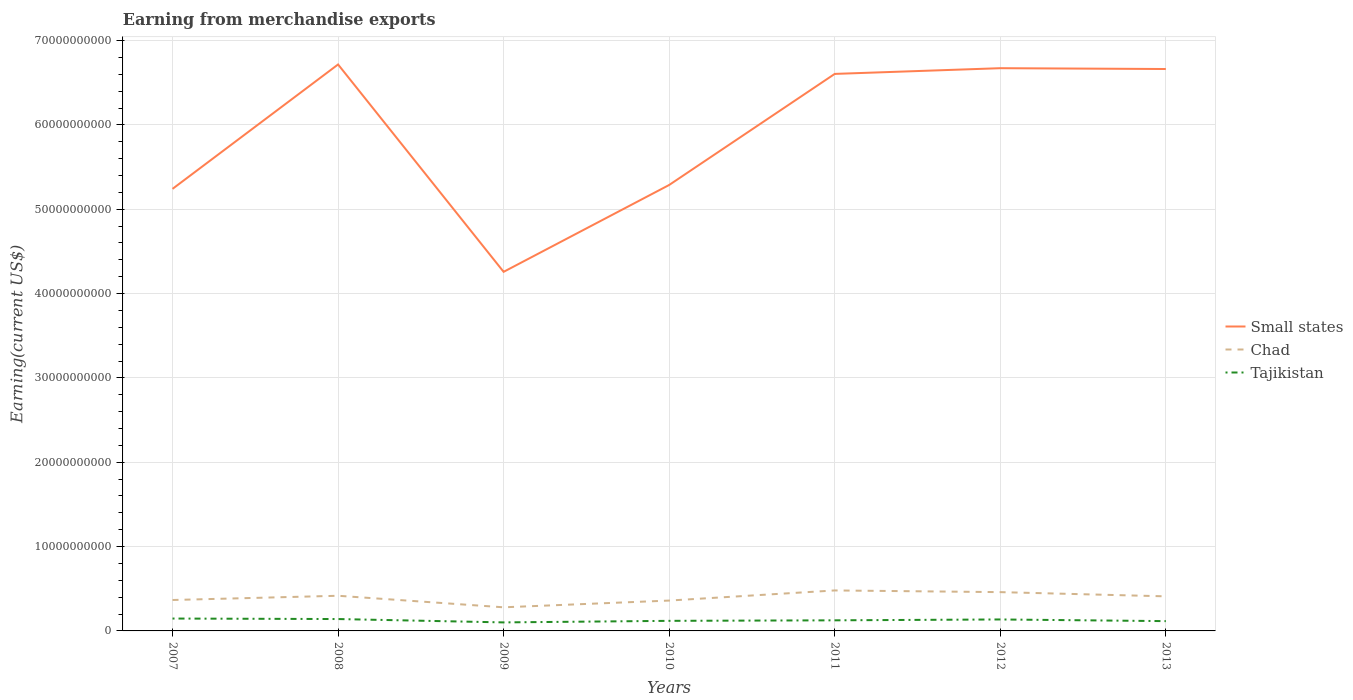Does the line corresponding to Tajikistan intersect with the line corresponding to Chad?
Provide a succinct answer. No. Is the number of lines equal to the number of legend labels?
Your answer should be very brief. Yes. Across all years, what is the maximum amount earned from merchandise exports in Tajikistan?
Give a very brief answer. 1.01e+09. What is the total amount earned from merchandise exports in Chad in the graph?
Your response must be concise. -6.31e+08. How many lines are there?
Give a very brief answer. 3. How many years are there in the graph?
Provide a succinct answer. 7. Does the graph contain any zero values?
Keep it short and to the point. No. Where does the legend appear in the graph?
Make the answer very short. Center right. What is the title of the graph?
Provide a short and direct response. Earning from merchandise exports. What is the label or title of the X-axis?
Provide a succinct answer. Years. What is the label or title of the Y-axis?
Provide a short and direct response. Earning(current US$). What is the Earning(current US$) of Small states in 2007?
Your answer should be compact. 5.24e+1. What is the Earning(current US$) in Chad in 2007?
Your answer should be very brief. 3.67e+09. What is the Earning(current US$) in Tajikistan in 2007?
Provide a short and direct response. 1.47e+09. What is the Earning(current US$) in Small states in 2008?
Your answer should be very brief. 6.72e+1. What is the Earning(current US$) in Chad in 2008?
Provide a succinct answer. 4.17e+09. What is the Earning(current US$) of Tajikistan in 2008?
Provide a succinct answer. 1.41e+09. What is the Earning(current US$) in Small states in 2009?
Provide a succinct answer. 4.26e+1. What is the Earning(current US$) of Chad in 2009?
Offer a terse response. 2.80e+09. What is the Earning(current US$) of Tajikistan in 2009?
Provide a succinct answer. 1.01e+09. What is the Earning(current US$) of Small states in 2010?
Ensure brevity in your answer.  5.29e+1. What is the Earning(current US$) of Chad in 2010?
Your answer should be very brief. 3.60e+09. What is the Earning(current US$) in Tajikistan in 2010?
Your response must be concise. 1.20e+09. What is the Earning(current US$) of Small states in 2011?
Your answer should be very brief. 6.60e+1. What is the Earning(current US$) of Chad in 2011?
Ensure brevity in your answer.  4.80e+09. What is the Earning(current US$) in Tajikistan in 2011?
Ensure brevity in your answer.  1.26e+09. What is the Earning(current US$) of Small states in 2012?
Offer a terse response. 6.67e+1. What is the Earning(current US$) of Chad in 2012?
Ensure brevity in your answer.  4.60e+09. What is the Earning(current US$) of Tajikistan in 2012?
Make the answer very short. 1.36e+09. What is the Earning(current US$) in Small states in 2013?
Offer a very short reply. 6.66e+1. What is the Earning(current US$) in Chad in 2013?
Offer a very short reply. 4.10e+09. What is the Earning(current US$) in Tajikistan in 2013?
Provide a short and direct response. 1.16e+09. Across all years, what is the maximum Earning(current US$) of Small states?
Offer a terse response. 6.72e+1. Across all years, what is the maximum Earning(current US$) of Chad?
Provide a short and direct response. 4.80e+09. Across all years, what is the maximum Earning(current US$) in Tajikistan?
Your answer should be compact. 1.47e+09. Across all years, what is the minimum Earning(current US$) of Small states?
Your answer should be compact. 4.26e+1. Across all years, what is the minimum Earning(current US$) in Chad?
Your response must be concise. 2.80e+09. Across all years, what is the minimum Earning(current US$) of Tajikistan?
Give a very brief answer. 1.01e+09. What is the total Earning(current US$) of Small states in the graph?
Make the answer very short. 4.14e+11. What is the total Earning(current US$) of Chad in the graph?
Your response must be concise. 2.77e+1. What is the total Earning(current US$) in Tajikistan in the graph?
Ensure brevity in your answer.  8.86e+09. What is the difference between the Earning(current US$) of Small states in 2007 and that in 2008?
Your response must be concise. -1.47e+1. What is the difference between the Earning(current US$) of Chad in 2007 and that in 2008?
Keep it short and to the point. -5.02e+08. What is the difference between the Earning(current US$) in Tajikistan in 2007 and that in 2008?
Make the answer very short. 5.93e+07. What is the difference between the Earning(current US$) of Small states in 2007 and that in 2009?
Provide a short and direct response. 9.84e+09. What is the difference between the Earning(current US$) in Chad in 2007 and that in 2009?
Ensure brevity in your answer.  8.66e+08. What is the difference between the Earning(current US$) in Tajikistan in 2007 and that in 2009?
Keep it short and to the point. 4.58e+08. What is the difference between the Earning(current US$) in Small states in 2007 and that in 2010?
Keep it short and to the point. -4.63e+08. What is the difference between the Earning(current US$) of Chad in 2007 and that in 2010?
Provide a short and direct response. 6.62e+07. What is the difference between the Earning(current US$) in Tajikistan in 2007 and that in 2010?
Provide a succinct answer. 2.73e+08. What is the difference between the Earning(current US$) in Small states in 2007 and that in 2011?
Give a very brief answer. -1.36e+1. What is the difference between the Earning(current US$) of Chad in 2007 and that in 2011?
Offer a very short reply. -1.13e+09. What is the difference between the Earning(current US$) of Tajikistan in 2007 and that in 2011?
Offer a terse response. 2.11e+08. What is the difference between the Earning(current US$) of Small states in 2007 and that in 2012?
Provide a short and direct response. -1.43e+1. What is the difference between the Earning(current US$) of Chad in 2007 and that in 2012?
Ensure brevity in your answer.  -9.34e+08. What is the difference between the Earning(current US$) of Tajikistan in 2007 and that in 2012?
Give a very brief answer. 1.08e+08. What is the difference between the Earning(current US$) of Small states in 2007 and that in 2013?
Provide a short and direct response. -1.42e+1. What is the difference between the Earning(current US$) in Chad in 2007 and that in 2013?
Your response must be concise. -4.34e+08. What is the difference between the Earning(current US$) in Tajikistan in 2007 and that in 2013?
Make the answer very short. 3.07e+08. What is the difference between the Earning(current US$) in Small states in 2008 and that in 2009?
Provide a short and direct response. 2.46e+1. What is the difference between the Earning(current US$) of Chad in 2008 and that in 2009?
Offer a very short reply. 1.37e+09. What is the difference between the Earning(current US$) in Tajikistan in 2008 and that in 2009?
Offer a terse response. 3.98e+08. What is the difference between the Earning(current US$) in Small states in 2008 and that in 2010?
Offer a very short reply. 1.43e+1. What is the difference between the Earning(current US$) of Chad in 2008 and that in 2010?
Provide a succinct answer. 5.69e+08. What is the difference between the Earning(current US$) of Tajikistan in 2008 and that in 2010?
Provide a short and direct response. 2.13e+08. What is the difference between the Earning(current US$) of Small states in 2008 and that in 2011?
Offer a very short reply. 1.12e+09. What is the difference between the Earning(current US$) of Chad in 2008 and that in 2011?
Provide a short and direct response. -6.31e+08. What is the difference between the Earning(current US$) of Tajikistan in 2008 and that in 2011?
Keep it short and to the point. 1.52e+08. What is the difference between the Earning(current US$) of Small states in 2008 and that in 2012?
Ensure brevity in your answer.  4.41e+08. What is the difference between the Earning(current US$) of Chad in 2008 and that in 2012?
Ensure brevity in your answer.  -4.31e+08. What is the difference between the Earning(current US$) of Tajikistan in 2008 and that in 2012?
Offer a very short reply. 4.90e+07. What is the difference between the Earning(current US$) of Small states in 2008 and that in 2013?
Offer a terse response. 5.39e+08. What is the difference between the Earning(current US$) in Chad in 2008 and that in 2013?
Offer a terse response. 6.86e+07. What is the difference between the Earning(current US$) in Tajikistan in 2008 and that in 2013?
Offer a terse response. 2.48e+08. What is the difference between the Earning(current US$) of Small states in 2009 and that in 2010?
Keep it short and to the point. -1.03e+1. What is the difference between the Earning(current US$) of Chad in 2009 and that in 2010?
Your response must be concise. -8.00e+08. What is the difference between the Earning(current US$) in Tajikistan in 2009 and that in 2010?
Your response must be concise. -1.85e+08. What is the difference between the Earning(current US$) in Small states in 2009 and that in 2011?
Ensure brevity in your answer.  -2.35e+1. What is the difference between the Earning(current US$) in Chad in 2009 and that in 2011?
Make the answer very short. -2.00e+09. What is the difference between the Earning(current US$) of Tajikistan in 2009 and that in 2011?
Make the answer very short. -2.46e+08. What is the difference between the Earning(current US$) in Small states in 2009 and that in 2012?
Your answer should be very brief. -2.41e+1. What is the difference between the Earning(current US$) of Chad in 2009 and that in 2012?
Provide a short and direct response. -1.80e+09. What is the difference between the Earning(current US$) of Tajikistan in 2009 and that in 2012?
Your answer should be compact. -3.49e+08. What is the difference between the Earning(current US$) of Small states in 2009 and that in 2013?
Provide a short and direct response. -2.40e+1. What is the difference between the Earning(current US$) of Chad in 2009 and that in 2013?
Your answer should be very brief. -1.30e+09. What is the difference between the Earning(current US$) of Tajikistan in 2009 and that in 2013?
Your response must be concise. -1.51e+08. What is the difference between the Earning(current US$) in Small states in 2010 and that in 2011?
Offer a very short reply. -1.32e+1. What is the difference between the Earning(current US$) of Chad in 2010 and that in 2011?
Provide a succinct answer. -1.20e+09. What is the difference between the Earning(current US$) in Tajikistan in 2010 and that in 2011?
Make the answer very short. -6.15e+07. What is the difference between the Earning(current US$) in Small states in 2010 and that in 2012?
Offer a terse response. -1.38e+1. What is the difference between the Earning(current US$) of Chad in 2010 and that in 2012?
Offer a terse response. -1.00e+09. What is the difference between the Earning(current US$) of Tajikistan in 2010 and that in 2012?
Ensure brevity in your answer.  -1.64e+08. What is the difference between the Earning(current US$) of Small states in 2010 and that in 2013?
Your answer should be very brief. -1.37e+1. What is the difference between the Earning(current US$) in Chad in 2010 and that in 2013?
Offer a terse response. -5.00e+08. What is the difference between the Earning(current US$) of Tajikistan in 2010 and that in 2013?
Ensure brevity in your answer.  3.43e+07. What is the difference between the Earning(current US$) of Small states in 2011 and that in 2012?
Provide a short and direct response. -6.77e+08. What is the difference between the Earning(current US$) in Chad in 2011 and that in 2012?
Offer a terse response. 2.00e+08. What is the difference between the Earning(current US$) in Tajikistan in 2011 and that in 2012?
Offer a terse response. -1.03e+08. What is the difference between the Earning(current US$) in Small states in 2011 and that in 2013?
Keep it short and to the point. -5.80e+08. What is the difference between the Earning(current US$) in Chad in 2011 and that in 2013?
Ensure brevity in your answer.  7.00e+08. What is the difference between the Earning(current US$) in Tajikistan in 2011 and that in 2013?
Offer a terse response. 9.58e+07. What is the difference between the Earning(current US$) in Small states in 2012 and that in 2013?
Keep it short and to the point. 9.76e+07. What is the difference between the Earning(current US$) of Chad in 2012 and that in 2013?
Offer a very short reply. 5.00e+08. What is the difference between the Earning(current US$) in Tajikistan in 2012 and that in 2013?
Make the answer very short. 1.99e+08. What is the difference between the Earning(current US$) of Small states in 2007 and the Earning(current US$) of Chad in 2008?
Provide a succinct answer. 4.82e+1. What is the difference between the Earning(current US$) in Small states in 2007 and the Earning(current US$) in Tajikistan in 2008?
Your answer should be compact. 5.10e+1. What is the difference between the Earning(current US$) of Chad in 2007 and the Earning(current US$) of Tajikistan in 2008?
Ensure brevity in your answer.  2.26e+09. What is the difference between the Earning(current US$) in Small states in 2007 and the Earning(current US$) in Chad in 2009?
Your response must be concise. 4.96e+1. What is the difference between the Earning(current US$) of Small states in 2007 and the Earning(current US$) of Tajikistan in 2009?
Provide a succinct answer. 5.14e+1. What is the difference between the Earning(current US$) of Chad in 2007 and the Earning(current US$) of Tajikistan in 2009?
Your answer should be compact. 2.66e+09. What is the difference between the Earning(current US$) of Small states in 2007 and the Earning(current US$) of Chad in 2010?
Your answer should be compact. 4.88e+1. What is the difference between the Earning(current US$) of Small states in 2007 and the Earning(current US$) of Tajikistan in 2010?
Provide a succinct answer. 5.12e+1. What is the difference between the Earning(current US$) in Chad in 2007 and the Earning(current US$) in Tajikistan in 2010?
Offer a terse response. 2.47e+09. What is the difference between the Earning(current US$) in Small states in 2007 and the Earning(current US$) in Chad in 2011?
Offer a very short reply. 4.76e+1. What is the difference between the Earning(current US$) in Small states in 2007 and the Earning(current US$) in Tajikistan in 2011?
Keep it short and to the point. 5.12e+1. What is the difference between the Earning(current US$) of Chad in 2007 and the Earning(current US$) of Tajikistan in 2011?
Ensure brevity in your answer.  2.41e+09. What is the difference between the Earning(current US$) in Small states in 2007 and the Earning(current US$) in Chad in 2012?
Your answer should be compact. 4.78e+1. What is the difference between the Earning(current US$) in Small states in 2007 and the Earning(current US$) in Tajikistan in 2012?
Offer a terse response. 5.11e+1. What is the difference between the Earning(current US$) of Chad in 2007 and the Earning(current US$) of Tajikistan in 2012?
Offer a terse response. 2.31e+09. What is the difference between the Earning(current US$) in Small states in 2007 and the Earning(current US$) in Chad in 2013?
Ensure brevity in your answer.  4.83e+1. What is the difference between the Earning(current US$) of Small states in 2007 and the Earning(current US$) of Tajikistan in 2013?
Keep it short and to the point. 5.13e+1. What is the difference between the Earning(current US$) of Chad in 2007 and the Earning(current US$) of Tajikistan in 2013?
Your answer should be very brief. 2.51e+09. What is the difference between the Earning(current US$) of Small states in 2008 and the Earning(current US$) of Chad in 2009?
Provide a short and direct response. 6.44e+1. What is the difference between the Earning(current US$) of Small states in 2008 and the Earning(current US$) of Tajikistan in 2009?
Provide a short and direct response. 6.62e+1. What is the difference between the Earning(current US$) of Chad in 2008 and the Earning(current US$) of Tajikistan in 2009?
Your answer should be compact. 3.16e+09. What is the difference between the Earning(current US$) in Small states in 2008 and the Earning(current US$) in Chad in 2010?
Provide a short and direct response. 6.36e+1. What is the difference between the Earning(current US$) of Small states in 2008 and the Earning(current US$) of Tajikistan in 2010?
Give a very brief answer. 6.60e+1. What is the difference between the Earning(current US$) of Chad in 2008 and the Earning(current US$) of Tajikistan in 2010?
Ensure brevity in your answer.  2.97e+09. What is the difference between the Earning(current US$) in Small states in 2008 and the Earning(current US$) in Chad in 2011?
Keep it short and to the point. 6.24e+1. What is the difference between the Earning(current US$) in Small states in 2008 and the Earning(current US$) in Tajikistan in 2011?
Give a very brief answer. 6.59e+1. What is the difference between the Earning(current US$) of Chad in 2008 and the Earning(current US$) of Tajikistan in 2011?
Provide a short and direct response. 2.91e+09. What is the difference between the Earning(current US$) in Small states in 2008 and the Earning(current US$) in Chad in 2012?
Offer a terse response. 6.26e+1. What is the difference between the Earning(current US$) of Small states in 2008 and the Earning(current US$) of Tajikistan in 2012?
Ensure brevity in your answer.  6.58e+1. What is the difference between the Earning(current US$) in Chad in 2008 and the Earning(current US$) in Tajikistan in 2012?
Provide a short and direct response. 2.81e+09. What is the difference between the Earning(current US$) in Small states in 2008 and the Earning(current US$) in Chad in 2013?
Provide a short and direct response. 6.31e+1. What is the difference between the Earning(current US$) of Small states in 2008 and the Earning(current US$) of Tajikistan in 2013?
Give a very brief answer. 6.60e+1. What is the difference between the Earning(current US$) in Chad in 2008 and the Earning(current US$) in Tajikistan in 2013?
Your answer should be very brief. 3.01e+09. What is the difference between the Earning(current US$) of Small states in 2009 and the Earning(current US$) of Chad in 2010?
Give a very brief answer. 3.90e+1. What is the difference between the Earning(current US$) in Small states in 2009 and the Earning(current US$) in Tajikistan in 2010?
Offer a very short reply. 4.14e+1. What is the difference between the Earning(current US$) in Chad in 2009 and the Earning(current US$) in Tajikistan in 2010?
Provide a short and direct response. 1.60e+09. What is the difference between the Earning(current US$) in Small states in 2009 and the Earning(current US$) in Chad in 2011?
Keep it short and to the point. 3.78e+1. What is the difference between the Earning(current US$) of Small states in 2009 and the Earning(current US$) of Tajikistan in 2011?
Keep it short and to the point. 4.13e+1. What is the difference between the Earning(current US$) in Chad in 2009 and the Earning(current US$) in Tajikistan in 2011?
Offer a very short reply. 1.54e+09. What is the difference between the Earning(current US$) of Small states in 2009 and the Earning(current US$) of Chad in 2012?
Provide a short and direct response. 3.80e+1. What is the difference between the Earning(current US$) of Small states in 2009 and the Earning(current US$) of Tajikistan in 2012?
Provide a succinct answer. 4.12e+1. What is the difference between the Earning(current US$) of Chad in 2009 and the Earning(current US$) of Tajikistan in 2012?
Provide a short and direct response. 1.44e+09. What is the difference between the Earning(current US$) of Small states in 2009 and the Earning(current US$) of Chad in 2013?
Provide a succinct answer. 3.85e+1. What is the difference between the Earning(current US$) of Small states in 2009 and the Earning(current US$) of Tajikistan in 2013?
Keep it short and to the point. 4.14e+1. What is the difference between the Earning(current US$) of Chad in 2009 and the Earning(current US$) of Tajikistan in 2013?
Give a very brief answer. 1.64e+09. What is the difference between the Earning(current US$) in Small states in 2010 and the Earning(current US$) in Chad in 2011?
Keep it short and to the point. 4.81e+1. What is the difference between the Earning(current US$) in Small states in 2010 and the Earning(current US$) in Tajikistan in 2011?
Your answer should be compact. 5.16e+1. What is the difference between the Earning(current US$) of Chad in 2010 and the Earning(current US$) of Tajikistan in 2011?
Keep it short and to the point. 2.34e+09. What is the difference between the Earning(current US$) in Small states in 2010 and the Earning(current US$) in Chad in 2012?
Provide a short and direct response. 4.83e+1. What is the difference between the Earning(current US$) in Small states in 2010 and the Earning(current US$) in Tajikistan in 2012?
Give a very brief answer. 5.15e+1. What is the difference between the Earning(current US$) of Chad in 2010 and the Earning(current US$) of Tajikistan in 2012?
Keep it short and to the point. 2.24e+09. What is the difference between the Earning(current US$) in Small states in 2010 and the Earning(current US$) in Chad in 2013?
Give a very brief answer. 4.88e+1. What is the difference between the Earning(current US$) of Small states in 2010 and the Earning(current US$) of Tajikistan in 2013?
Offer a terse response. 5.17e+1. What is the difference between the Earning(current US$) of Chad in 2010 and the Earning(current US$) of Tajikistan in 2013?
Offer a terse response. 2.44e+09. What is the difference between the Earning(current US$) in Small states in 2011 and the Earning(current US$) in Chad in 2012?
Keep it short and to the point. 6.14e+1. What is the difference between the Earning(current US$) of Small states in 2011 and the Earning(current US$) of Tajikistan in 2012?
Give a very brief answer. 6.47e+1. What is the difference between the Earning(current US$) of Chad in 2011 and the Earning(current US$) of Tajikistan in 2012?
Offer a very short reply. 3.44e+09. What is the difference between the Earning(current US$) of Small states in 2011 and the Earning(current US$) of Chad in 2013?
Your answer should be very brief. 6.19e+1. What is the difference between the Earning(current US$) of Small states in 2011 and the Earning(current US$) of Tajikistan in 2013?
Provide a short and direct response. 6.49e+1. What is the difference between the Earning(current US$) in Chad in 2011 and the Earning(current US$) in Tajikistan in 2013?
Your answer should be very brief. 3.64e+09. What is the difference between the Earning(current US$) of Small states in 2012 and the Earning(current US$) of Chad in 2013?
Offer a very short reply. 6.26e+1. What is the difference between the Earning(current US$) in Small states in 2012 and the Earning(current US$) in Tajikistan in 2013?
Keep it short and to the point. 6.56e+1. What is the difference between the Earning(current US$) of Chad in 2012 and the Earning(current US$) of Tajikistan in 2013?
Offer a very short reply. 3.44e+09. What is the average Earning(current US$) in Small states per year?
Your response must be concise. 5.92e+1. What is the average Earning(current US$) of Chad per year?
Keep it short and to the point. 3.96e+09. What is the average Earning(current US$) of Tajikistan per year?
Give a very brief answer. 1.27e+09. In the year 2007, what is the difference between the Earning(current US$) in Small states and Earning(current US$) in Chad?
Your answer should be very brief. 4.87e+1. In the year 2007, what is the difference between the Earning(current US$) of Small states and Earning(current US$) of Tajikistan?
Your answer should be very brief. 5.09e+1. In the year 2007, what is the difference between the Earning(current US$) in Chad and Earning(current US$) in Tajikistan?
Provide a short and direct response. 2.20e+09. In the year 2008, what is the difference between the Earning(current US$) in Small states and Earning(current US$) in Chad?
Offer a very short reply. 6.30e+1. In the year 2008, what is the difference between the Earning(current US$) of Small states and Earning(current US$) of Tajikistan?
Your response must be concise. 6.58e+1. In the year 2008, what is the difference between the Earning(current US$) in Chad and Earning(current US$) in Tajikistan?
Your answer should be compact. 2.76e+09. In the year 2009, what is the difference between the Earning(current US$) of Small states and Earning(current US$) of Chad?
Keep it short and to the point. 3.98e+1. In the year 2009, what is the difference between the Earning(current US$) in Small states and Earning(current US$) in Tajikistan?
Ensure brevity in your answer.  4.16e+1. In the year 2009, what is the difference between the Earning(current US$) in Chad and Earning(current US$) in Tajikistan?
Offer a very short reply. 1.79e+09. In the year 2010, what is the difference between the Earning(current US$) in Small states and Earning(current US$) in Chad?
Offer a very short reply. 4.93e+1. In the year 2010, what is the difference between the Earning(current US$) in Small states and Earning(current US$) in Tajikistan?
Your answer should be very brief. 5.17e+1. In the year 2010, what is the difference between the Earning(current US$) of Chad and Earning(current US$) of Tajikistan?
Offer a very short reply. 2.40e+09. In the year 2011, what is the difference between the Earning(current US$) in Small states and Earning(current US$) in Chad?
Offer a very short reply. 6.12e+1. In the year 2011, what is the difference between the Earning(current US$) in Small states and Earning(current US$) in Tajikistan?
Offer a terse response. 6.48e+1. In the year 2011, what is the difference between the Earning(current US$) of Chad and Earning(current US$) of Tajikistan?
Offer a very short reply. 3.54e+09. In the year 2012, what is the difference between the Earning(current US$) of Small states and Earning(current US$) of Chad?
Give a very brief answer. 6.21e+1. In the year 2012, what is the difference between the Earning(current US$) of Small states and Earning(current US$) of Tajikistan?
Offer a very short reply. 6.54e+1. In the year 2012, what is the difference between the Earning(current US$) of Chad and Earning(current US$) of Tajikistan?
Your answer should be very brief. 3.24e+09. In the year 2013, what is the difference between the Earning(current US$) of Small states and Earning(current US$) of Chad?
Ensure brevity in your answer.  6.25e+1. In the year 2013, what is the difference between the Earning(current US$) in Small states and Earning(current US$) in Tajikistan?
Your response must be concise. 6.55e+1. In the year 2013, what is the difference between the Earning(current US$) of Chad and Earning(current US$) of Tajikistan?
Offer a very short reply. 2.94e+09. What is the ratio of the Earning(current US$) in Small states in 2007 to that in 2008?
Give a very brief answer. 0.78. What is the ratio of the Earning(current US$) of Chad in 2007 to that in 2008?
Ensure brevity in your answer.  0.88. What is the ratio of the Earning(current US$) of Tajikistan in 2007 to that in 2008?
Offer a very short reply. 1.04. What is the ratio of the Earning(current US$) in Small states in 2007 to that in 2009?
Give a very brief answer. 1.23. What is the ratio of the Earning(current US$) of Chad in 2007 to that in 2009?
Keep it short and to the point. 1.31. What is the ratio of the Earning(current US$) of Tajikistan in 2007 to that in 2009?
Provide a short and direct response. 1.45. What is the ratio of the Earning(current US$) of Chad in 2007 to that in 2010?
Keep it short and to the point. 1.02. What is the ratio of the Earning(current US$) in Tajikistan in 2007 to that in 2010?
Provide a short and direct response. 1.23. What is the ratio of the Earning(current US$) in Small states in 2007 to that in 2011?
Provide a succinct answer. 0.79. What is the ratio of the Earning(current US$) of Chad in 2007 to that in 2011?
Provide a short and direct response. 0.76. What is the ratio of the Earning(current US$) in Tajikistan in 2007 to that in 2011?
Give a very brief answer. 1.17. What is the ratio of the Earning(current US$) in Small states in 2007 to that in 2012?
Your answer should be very brief. 0.79. What is the ratio of the Earning(current US$) of Chad in 2007 to that in 2012?
Keep it short and to the point. 0.8. What is the ratio of the Earning(current US$) in Tajikistan in 2007 to that in 2012?
Give a very brief answer. 1.08. What is the ratio of the Earning(current US$) of Small states in 2007 to that in 2013?
Give a very brief answer. 0.79. What is the ratio of the Earning(current US$) in Chad in 2007 to that in 2013?
Your answer should be very brief. 0.89. What is the ratio of the Earning(current US$) in Tajikistan in 2007 to that in 2013?
Your answer should be very brief. 1.26. What is the ratio of the Earning(current US$) of Small states in 2008 to that in 2009?
Your response must be concise. 1.58. What is the ratio of the Earning(current US$) of Chad in 2008 to that in 2009?
Provide a short and direct response. 1.49. What is the ratio of the Earning(current US$) in Tajikistan in 2008 to that in 2009?
Offer a very short reply. 1.39. What is the ratio of the Earning(current US$) in Small states in 2008 to that in 2010?
Your answer should be very brief. 1.27. What is the ratio of the Earning(current US$) in Chad in 2008 to that in 2010?
Offer a terse response. 1.16. What is the ratio of the Earning(current US$) of Tajikistan in 2008 to that in 2010?
Provide a succinct answer. 1.18. What is the ratio of the Earning(current US$) in Small states in 2008 to that in 2011?
Offer a terse response. 1.02. What is the ratio of the Earning(current US$) of Chad in 2008 to that in 2011?
Give a very brief answer. 0.87. What is the ratio of the Earning(current US$) of Tajikistan in 2008 to that in 2011?
Your answer should be very brief. 1.12. What is the ratio of the Earning(current US$) in Small states in 2008 to that in 2012?
Ensure brevity in your answer.  1.01. What is the ratio of the Earning(current US$) in Chad in 2008 to that in 2012?
Give a very brief answer. 0.91. What is the ratio of the Earning(current US$) in Tajikistan in 2008 to that in 2012?
Offer a very short reply. 1.04. What is the ratio of the Earning(current US$) of Chad in 2008 to that in 2013?
Provide a short and direct response. 1.02. What is the ratio of the Earning(current US$) of Tajikistan in 2008 to that in 2013?
Offer a terse response. 1.21. What is the ratio of the Earning(current US$) of Small states in 2009 to that in 2010?
Offer a terse response. 0.81. What is the ratio of the Earning(current US$) of Chad in 2009 to that in 2010?
Give a very brief answer. 0.78. What is the ratio of the Earning(current US$) of Tajikistan in 2009 to that in 2010?
Offer a very short reply. 0.85. What is the ratio of the Earning(current US$) in Small states in 2009 to that in 2011?
Provide a succinct answer. 0.64. What is the ratio of the Earning(current US$) in Chad in 2009 to that in 2011?
Offer a terse response. 0.58. What is the ratio of the Earning(current US$) in Tajikistan in 2009 to that in 2011?
Keep it short and to the point. 0.8. What is the ratio of the Earning(current US$) in Small states in 2009 to that in 2012?
Keep it short and to the point. 0.64. What is the ratio of the Earning(current US$) of Chad in 2009 to that in 2012?
Your response must be concise. 0.61. What is the ratio of the Earning(current US$) in Tajikistan in 2009 to that in 2012?
Your answer should be compact. 0.74. What is the ratio of the Earning(current US$) in Small states in 2009 to that in 2013?
Give a very brief answer. 0.64. What is the ratio of the Earning(current US$) in Chad in 2009 to that in 2013?
Provide a succinct answer. 0.68. What is the ratio of the Earning(current US$) of Tajikistan in 2009 to that in 2013?
Give a very brief answer. 0.87. What is the ratio of the Earning(current US$) of Small states in 2010 to that in 2011?
Provide a succinct answer. 0.8. What is the ratio of the Earning(current US$) in Tajikistan in 2010 to that in 2011?
Provide a short and direct response. 0.95. What is the ratio of the Earning(current US$) of Small states in 2010 to that in 2012?
Give a very brief answer. 0.79. What is the ratio of the Earning(current US$) of Chad in 2010 to that in 2012?
Your answer should be very brief. 0.78. What is the ratio of the Earning(current US$) of Tajikistan in 2010 to that in 2012?
Provide a succinct answer. 0.88. What is the ratio of the Earning(current US$) of Small states in 2010 to that in 2013?
Provide a succinct answer. 0.79. What is the ratio of the Earning(current US$) in Chad in 2010 to that in 2013?
Give a very brief answer. 0.88. What is the ratio of the Earning(current US$) in Tajikistan in 2010 to that in 2013?
Offer a terse response. 1.03. What is the ratio of the Earning(current US$) of Small states in 2011 to that in 2012?
Offer a terse response. 0.99. What is the ratio of the Earning(current US$) in Chad in 2011 to that in 2012?
Offer a terse response. 1.04. What is the ratio of the Earning(current US$) in Tajikistan in 2011 to that in 2012?
Your answer should be very brief. 0.92. What is the ratio of the Earning(current US$) of Small states in 2011 to that in 2013?
Your answer should be compact. 0.99. What is the ratio of the Earning(current US$) in Chad in 2011 to that in 2013?
Ensure brevity in your answer.  1.17. What is the ratio of the Earning(current US$) of Tajikistan in 2011 to that in 2013?
Keep it short and to the point. 1.08. What is the ratio of the Earning(current US$) of Small states in 2012 to that in 2013?
Ensure brevity in your answer.  1. What is the ratio of the Earning(current US$) of Chad in 2012 to that in 2013?
Ensure brevity in your answer.  1.12. What is the ratio of the Earning(current US$) of Tajikistan in 2012 to that in 2013?
Your response must be concise. 1.17. What is the difference between the highest and the second highest Earning(current US$) of Small states?
Make the answer very short. 4.41e+08. What is the difference between the highest and the second highest Earning(current US$) in Chad?
Your answer should be very brief. 2.00e+08. What is the difference between the highest and the second highest Earning(current US$) of Tajikistan?
Your answer should be compact. 5.93e+07. What is the difference between the highest and the lowest Earning(current US$) of Small states?
Your answer should be compact. 2.46e+1. What is the difference between the highest and the lowest Earning(current US$) in Tajikistan?
Provide a short and direct response. 4.58e+08. 